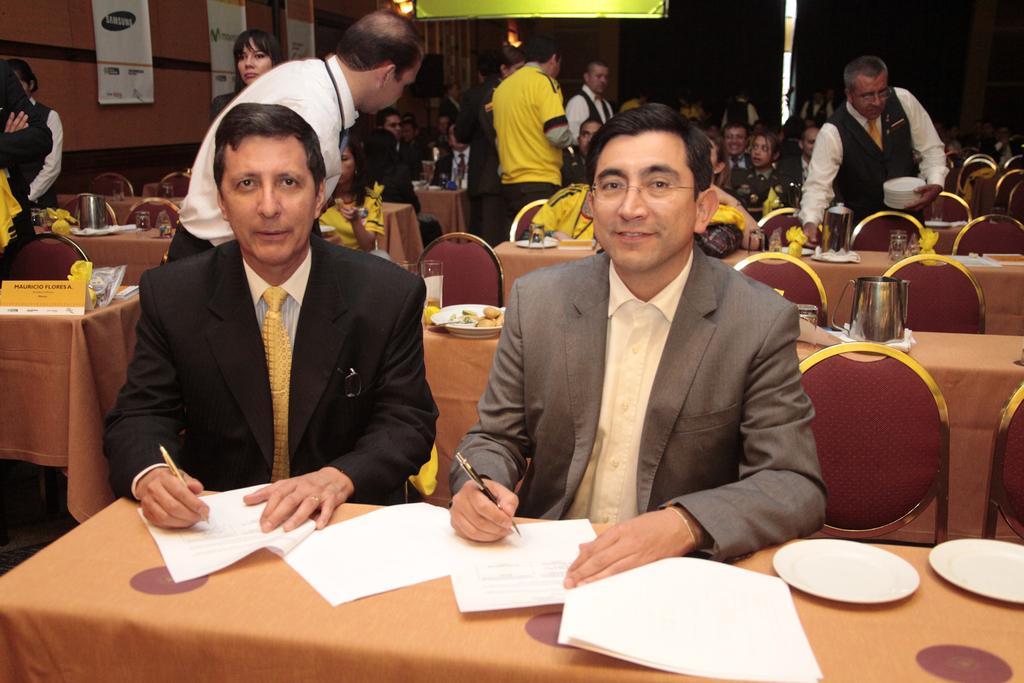How would you summarize this image in a sentence or two? In the picture we can see two men are sitting on the chairs near the table and writing something on the papers and they are in blazers, ties and shirts and behind them, we can see tables and chairs and we can see some people are sitting and some are standing and one man is collecting the plates and besides to them we can see a wall with some posters and beside it we can see the light. 